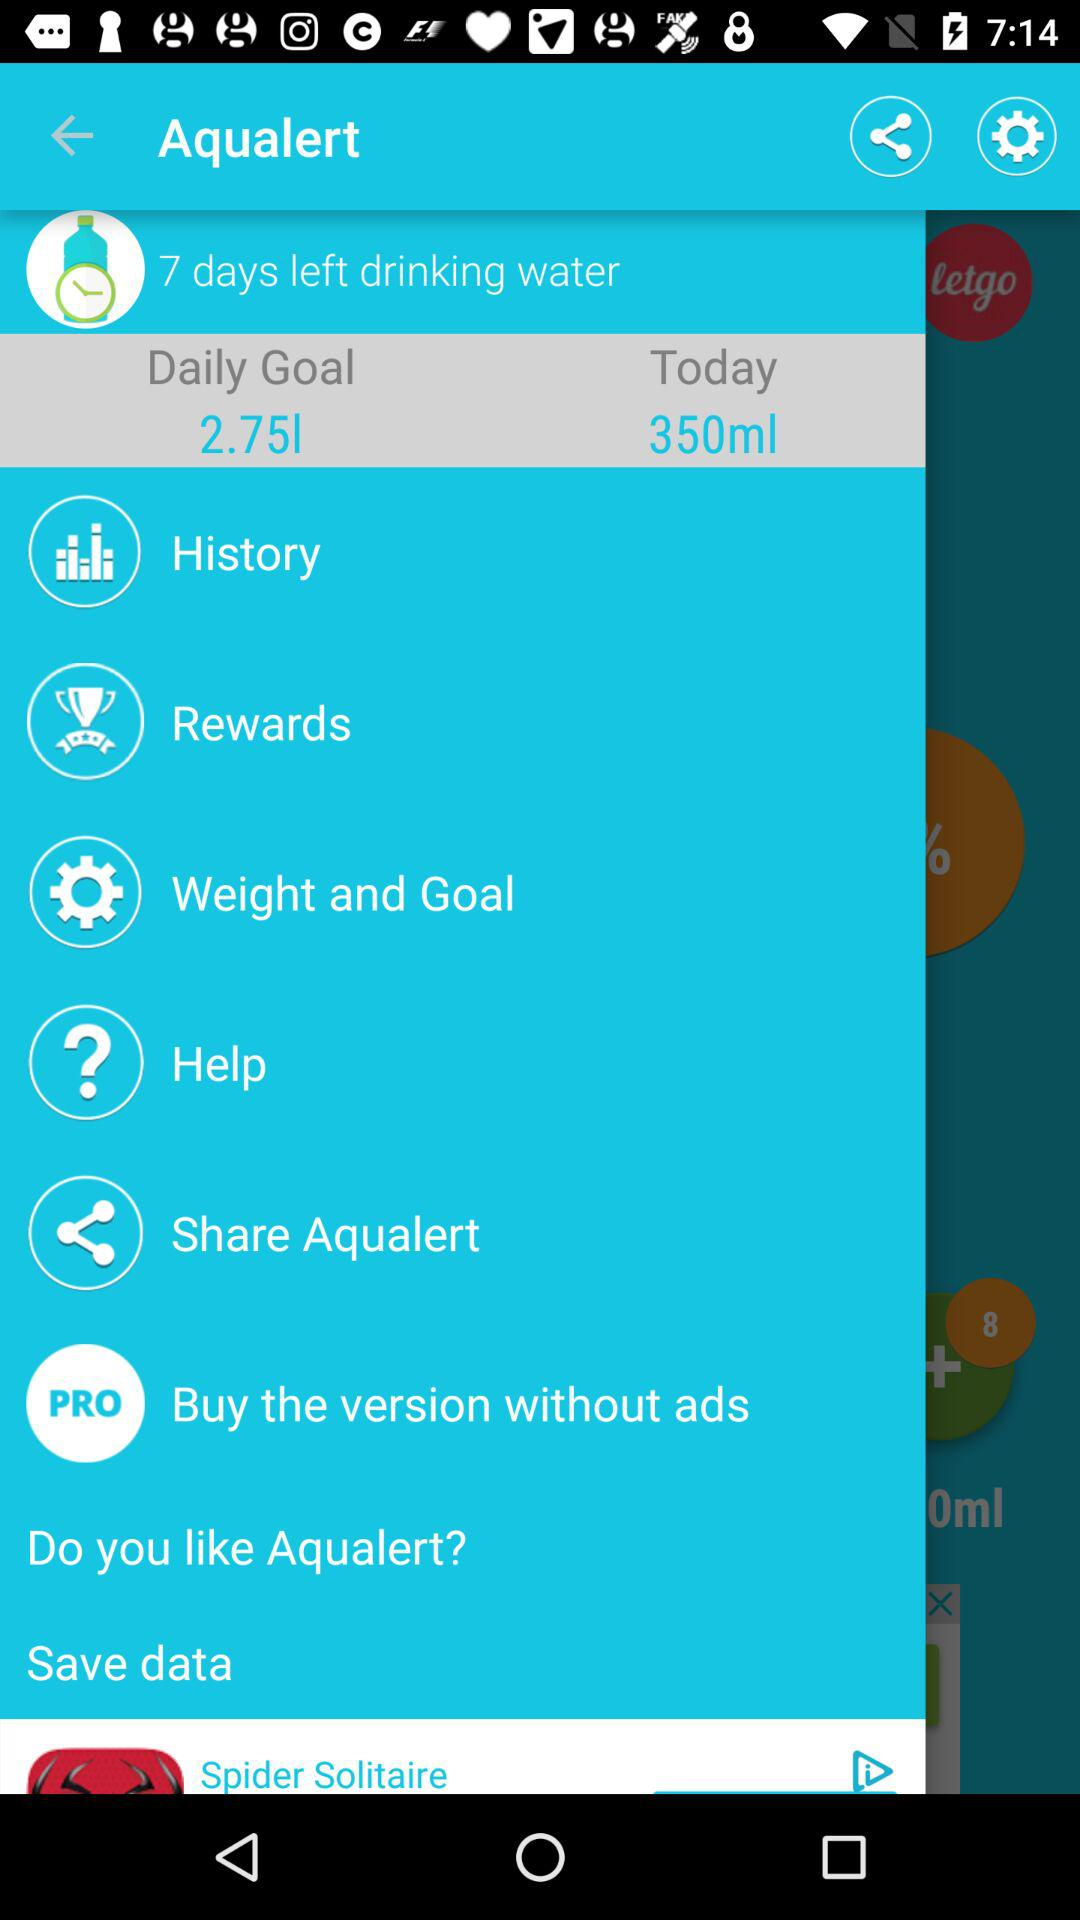What is the daily goal? The daily goal is 2.75 litres. 